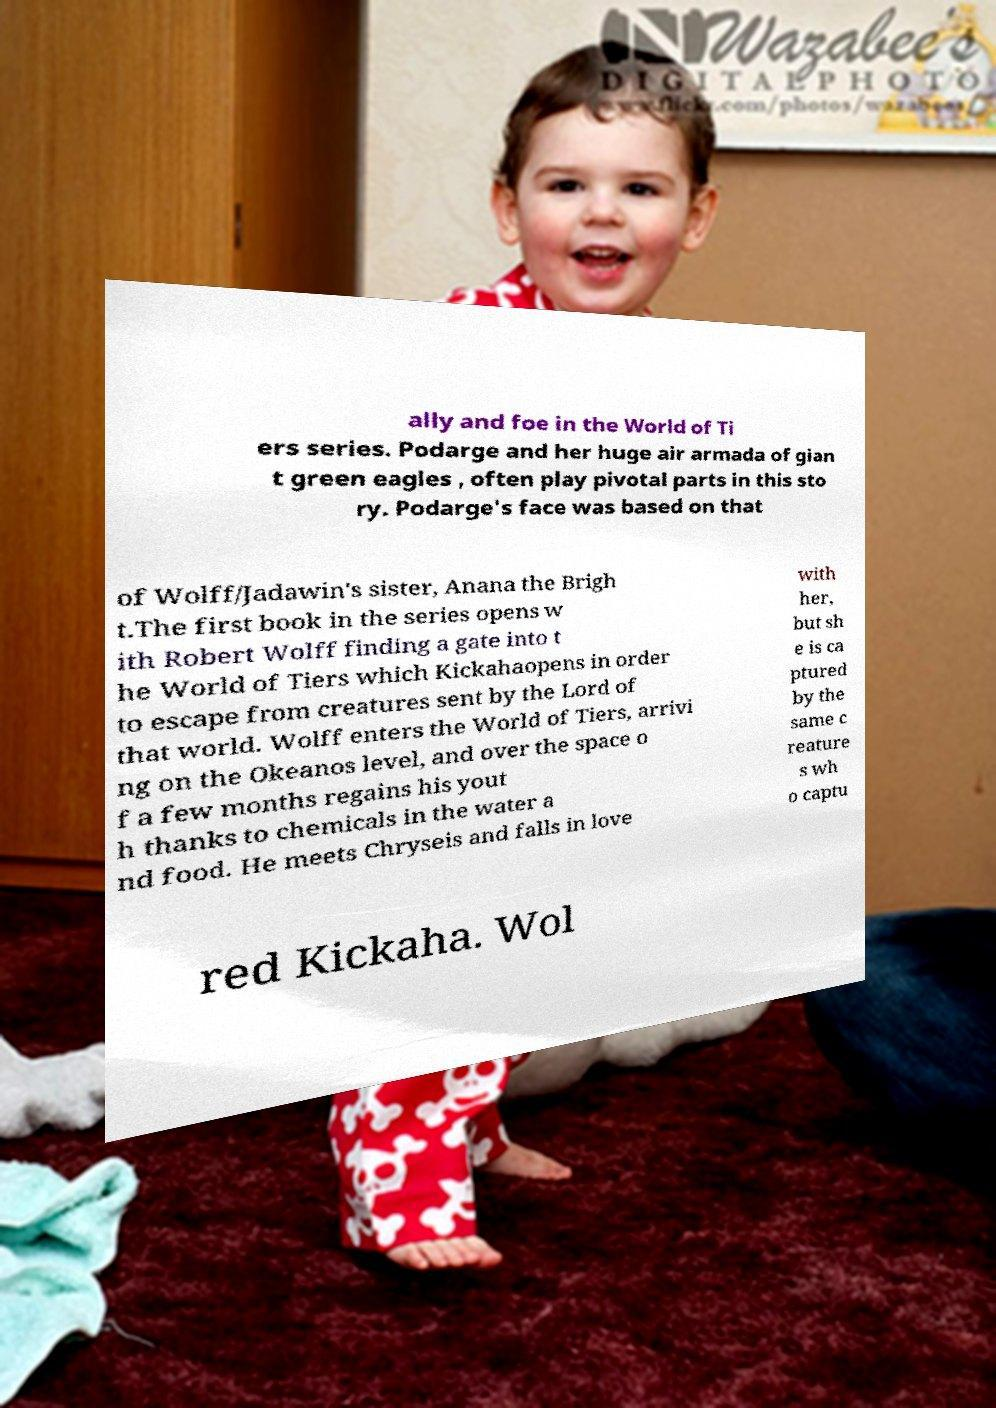For documentation purposes, I need the text within this image transcribed. Could you provide that? ally and foe in the World of Ti ers series. Podarge and her huge air armada of gian t green eagles , often play pivotal parts in this sto ry. Podarge's face was based on that of Wolff/Jadawin's sister, Anana the Brigh t.The first book in the series opens w ith Robert Wolff finding a gate into t he World of Tiers which Kickahaopens in order to escape from creatures sent by the Lord of that world. Wolff enters the World of Tiers, arrivi ng on the Okeanos level, and over the space o f a few months regains his yout h thanks to chemicals in the water a nd food. He meets Chryseis and falls in love with her, but sh e is ca ptured by the same c reature s wh o captu red Kickaha. Wol 